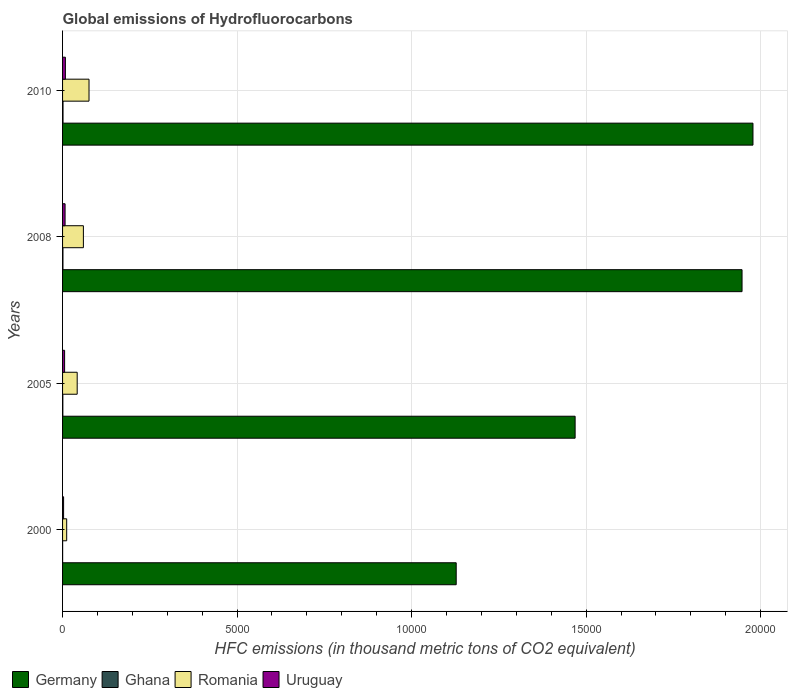How many groups of bars are there?
Your response must be concise. 4. Are the number of bars per tick equal to the number of legend labels?
Your answer should be very brief. Yes. How many bars are there on the 3rd tick from the bottom?
Offer a terse response. 4. Across all years, what is the maximum global emissions of Hydrofluorocarbons in Germany?
Provide a short and direct response. 1.98e+04. In which year was the global emissions of Hydrofluorocarbons in Uruguay minimum?
Offer a terse response. 2000. What is the total global emissions of Hydrofluorocarbons in Romania in the graph?
Your response must be concise. 1891.4. What is the difference between the global emissions of Hydrofluorocarbons in Germany in 2000 and that in 2005?
Make the answer very short. -3407. What is the difference between the global emissions of Hydrofluorocarbons in Romania in 2010 and the global emissions of Hydrofluorocarbons in Uruguay in 2000?
Keep it short and to the point. 728.7. What is the average global emissions of Hydrofluorocarbons in Romania per year?
Provide a succinct answer. 472.85. In the year 2010, what is the difference between the global emissions of Hydrofluorocarbons in Germany and global emissions of Hydrofluorocarbons in Ghana?
Ensure brevity in your answer.  1.98e+04. What is the ratio of the global emissions of Hydrofluorocarbons in Romania in 2005 to that in 2008?
Keep it short and to the point. 0.7. Is the difference between the global emissions of Hydrofluorocarbons in Germany in 2000 and 2005 greater than the difference between the global emissions of Hydrofluorocarbons in Ghana in 2000 and 2005?
Provide a succinct answer. No. What is the difference between the highest and the second highest global emissions of Hydrofluorocarbons in Romania?
Your answer should be compact. 161.6. What is the difference between the highest and the lowest global emissions of Hydrofluorocarbons in Germany?
Your answer should be very brief. 8502.4. In how many years, is the global emissions of Hydrofluorocarbons in Ghana greater than the average global emissions of Hydrofluorocarbons in Ghana taken over all years?
Provide a short and direct response. 2. Is the sum of the global emissions of Hydrofluorocarbons in Ghana in 2005 and 2008 greater than the maximum global emissions of Hydrofluorocarbons in Uruguay across all years?
Your answer should be very brief. No. Is it the case that in every year, the sum of the global emissions of Hydrofluorocarbons in Germany and global emissions of Hydrofluorocarbons in Romania is greater than the sum of global emissions of Hydrofluorocarbons in Uruguay and global emissions of Hydrofluorocarbons in Ghana?
Your answer should be compact. Yes. What does the 1st bar from the bottom in 2010 represents?
Your answer should be very brief. Germany. How many bars are there?
Offer a very short reply. 16. Are all the bars in the graph horizontal?
Offer a very short reply. Yes. What is the difference between two consecutive major ticks on the X-axis?
Offer a terse response. 5000. Does the graph contain any zero values?
Make the answer very short. No. Where does the legend appear in the graph?
Offer a terse response. Bottom left. How many legend labels are there?
Ensure brevity in your answer.  4. What is the title of the graph?
Your answer should be compact. Global emissions of Hydrofluorocarbons. Does "Bahamas" appear as one of the legend labels in the graph?
Offer a terse response. No. What is the label or title of the X-axis?
Make the answer very short. HFC emissions (in thousand metric tons of CO2 equivalent). What is the label or title of the Y-axis?
Give a very brief answer. Years. What is the HFC emissions (in thousand metric tons of CO2 equivalent) in Germany in 2000?
Your answer should be very brief. 1.13e+04. What is the HFC emissions (in thousand metric tons of CO2 equivalent) of Romania in 2000?
Offer a very short reply. 118.2. What is the HFC emissions (in thousand metric tons of CO2 equivalent) in Uruguay in 2000?
Your answer should be very brief. 29.3. What is the HFC emissions (in thousand metric tons of CO2 equivalent) in Germany in 2005?
Offer a very short reply. 1.47e+04. What is the HFC emissions (in thousand metric tons of CO2 equivalent) in Ghana in 2005?
Offer a very short reply. 7.8. What is the HFC emissions (in thousand metric tons of CO2 equivalent) of Romania in 2005?
Keep it short and to the point. 418.8. What is the HFC emissions (in thousand metric tons of CO2 equivalent) in Uruguay in 2005?
Your answer should be very brief. 58.7. What is the HFC emissions (in thousand metric tons of CO2 equivalent) in Germany in 2008?
Keep it short and to the point. 1.95e+04. What is the HFC emissions (in thousand metric tons of CO2 equivalent) of Ghana in 2008?
Keep it short and to the point. 11.2. What is the HFC emissions (in thousand metric tons of CO2 equivalent) of Romania in 2008?
Your answer should be compact. 596.4. What is the HFC emissions (in thousand metric tons of CO2 equivalent) in Uruguay in 2008?
Your answer should be compact. 71.8. What is the HFC emissions (in thousand metric tons of CO2 equivalent) of Germany in 2010?
Provide a succinct answer. 1.98e+04. What is the HFC emissions (in thousand metric tons of CO2 equivalent) of Romania in 2010?
Provide a short and direct response. 758. What is the HFC emissions (in thousand metric tons of CO2 equivalent) of Uruguay in 2010?
Your answer should be very brief. 81. Across all years, what is the maximum HFC emissions (in thousand metric tons of CO2 equivalent) of Germany?
Offer a very short reply. 1.98e+04. Across all years, what is the maximum HFC emissions (in thousand metric tons of CO2 equivalent) of Ghana?
Provide a short and direct response. 13. Across all years, what is the maximum HFC emissions (in thousand metric tons of CO2 equivalent) of Romania?
Provide a short and direct response. 758. Across all years, what is the minimum HFC emissions (in thousand metric tons of CO2 equivalent) of Germany?
Provide a succinct answer. 1.13e+04. Across all years, what is the minimum HFC emissions (in thousand metric tons of CO2 equivalent) of Romania?
Your answer should be very brief. 118.2. Across all years, what is the minimum HFC emissions (in thousand metric tons of CO2 equivalent) of Uruguay?
Your answer should be compact. 29.3. What is the total HFC emissions (in thousand metric tons of CO2 equivalent) of Germany in the graph?
Ensure brevity in your answer.  6.52e+04. What is the total HFC emissions (in thousand metric tons of CO2 equivalent) in Ghana in the graph?
Offer a very short reply. 33.9. What is the total HFC emissions (in thousand metric tons of CO2 equivalent) in Romania in the graph?
Your answer should be compact. 1891.4. What is the total HFC emissions (in thousand metric tons of CO2 equivalent) in Uruguay in the graph?
Your answer should be compact. 240.8. What is the difference between the HFC emissions (in thousand metric tons of CO2 equivalent) in Germany in 2000 and that in 2005?
Your response must be concise. -3407. What is the difference between the HFC emissions (in thousand metric tons of CO2 equivalent) in Ghana in 2000 and that in 2005?
Offer a very short reply. -5.9. What is the difference between the HFC emissions (in thousand metric tons of CO2 equivalent) of Romania in 2000 and that in 2005?
Ensure brevity in your answer.  -300.6. What is the difference between the HFC emissions (in thousand metric tons of CO2 equivalent) of Uruguay in 2000 and that in 2005?
Keep it short and to the point. -29.4. What is the difference between the HFC emissions (in thousand metric tons of CO2 equivalent) in Germany in 2000 and that in 2008?
Ensure brevity in your answer.  -8189.2. What is the difference between the HFC emissions (in thousand metric tons of CO2 equivalent) of Ghana in 2000 and that in 2008?
Provide a succinct answer. -9.3. What is the difference between the HFC emissions (in thousand metric tons of CO2 equivalent) of Romania in 2000 and that in 2008?
Keep it short and to the point. -478.2. What is the difference between the HFC emissions (in thousand metric tons of CO2 equivalent) in Uruguay in 2000 and that in 2008?
Offer a terse response. -42.5. What is the difference between the HFC emissions (in thousand metric tons of CO2 equivalent) of Germany in 2000 and that in 2010?
Your answer should be very brief. -8502.4. What is the difference between the HFC emissions (in thousand metric tons of CO2 equivalent) of Ghana in 2000 and that in 2010?
Keep it short and to the point. -11.1. What is the difference between the HFC emissions (in thousand metric tons of CO2 equivalent) of Romania in 2000 and that in 2010?
Provide a succinct answer. -639.8. What is the difference between the HFC emissions (in thousand metric tons of CO2 equivalent) of Uruguay in 2000 and that in 2010?
Give a very brief answer. -51.7. What is the difference between the HFC emissions (in thousand metric tons of CO2 equivalent) of Germany in 2005 and that in 2008?
Provide a succinct answer. -4782.2. What is the difference between the HFC emissions (in thousand metric tons of CO2 equivalent) of Romania in 2005 and that in 2008?
Keep it short and to the point. -177.6. What is the difference between the HFC emissions (in thousand metric tons of CO2 equivalent) of Uruguay in 2005 and that in 2008?
Keep it short and to the point. -13.1. What is the difference between the HFC emissions (in thousand metric tons of CO2 equivalent) in Germany in 2005 and that in 2010?
Provide a succinct answer. -5095.4. What is the difference between the HFC emissions (in thousand metric tons of CO2 equivalent) in Ghana in 2005 and that in 2010?
Provide a succinct answer. -5.2. What is the difference between the HFC emissions (in thousand metric tons of CO2 equivalent) in Romania in 2005 and that in 2010?
Your answer should be compact. -339.2. What is the difference between the HFC emissions (in thousand metric tons of CO2 equivalent) of Uruguay in 2005 and that in 2010?
Give a very brief answer. -22.3. What is the difference between the HFC emissions (in thousand metric tons of CO2 equivalent) in Germany in 2008 and that in 2010?
Keep it short and to the point. -313.2. What is the difference between the HFC emissions (in thousand metric tons of CO2 equivalent) of Romania in 2008 and that in 2010?
Provide a succinct answer. -161.6. What is the difference between the HFC emissions (in thousand metric tons of CO2 equivalent) of Uruguay in 2008 and that in 2010?
Offer a terse response. -9.2. What is the difference between the HFC emissions (in thousand metric tons of CO2 equivalent) in Germany in 2000 and the HFC emissions (in thousand metric tons of CO2 equivalent) in Ghana in 2005?
Offer a terse response. 1.13e+04. What is the difference between the HFC emissions (in thousand metric tons of CO2 equivalent) of Germany in 2000 and the HFC emissions (in thousand metric tons of CO2 equivalent) of Romania in 2005?
Keep it short and to the point. 1.09e+04. What is the difference between the HFC emissions (in thousand metric tons of CO2 equivalent) of Germany in 2000 and the HFC emissions (in thousand metric tons of CO2 equivalent) of Uruguay in 2005?
Offer a very short reply. 1.12e+04. What is the difference between the HFC emissions (in thousand metric tons of CO2 equivalent) of Ghana in 2000 and the HFC emissions (in thousand metric tons of CO2 equivalent) of Romania in 2005?
Offer a very short reply. -416.9. What is the difference between the HFC emissions (in thousand metric tons of CO2 equivalent) of Ghana in 2000 and the HFC emissions (in thousand metric tons of CO2 equivalent) of Uruguay in 2005?
Your answer should be very brief. -56.8. What is the difference between the HFC emissions (in thousand metric tons of CO2 equivalent) of Romania in 2000 and the HFC emissions (in thousand metric tons of CO2 equivalent) of Uruguay in 2005?
Ensure brevity in your answer.  59.5. What is the difference between the HFC emissions (in thousand metric tons of CO2 equivalent) in Germany in 2000 and the HFC emissions (in thousand metric tons of CO2 equivalent) in Ghana in 2008?
Your answer should be compact. 1.13e+04. What is the difference between the HFC emissions (in thousand metric tons of CO2 equivalent) in Germany in 2000 and the HFC emissions (in thousand metric tons of CO2 equivalent) in Romania in 2008?
Your answer should be very brief. 1.07e+04. What is the difference between the HFC emissions (in thousand metric tons of CO2 equivalent) in Germany in 2000 and the HFC emissions (in thousand metric tons of CO2 equivalent) in Uruguay in 2008?
Keep it short and to the point. 1.12e+04. What is the difference between the HFC emissions (in thousand metric tons of CO2 equivalent) in Ghana in 2000 and the HFC emissions (in thousand metric tons of CO2 equivalent) in Romania in 2008?
Your answer should be compact. -594.5. What is the difference between the HFC emissions (in thousand metric tons of CO2 equivalent) of Ghana in 2000 and the HFC emissions (in thousand metric tons of CO2 equivalent) of Uruguay in 2008?
Your answer should be very brief. -69.9. What is the difference between the HFC emissions (in thousand metric tons of CO2 equivalent) in Romania in 2000 and the HFC emissions (in thousand metric tons of CO2 equivalent) in Uruguay in 2008?
Ensure brevity in your answer.  46.4. What is the difference between the HFC emissions (in thousand metric tons of CO2 equivalent) in Germany in 2000 and the HFC emissions (in thousand metric tons of CO2 equivalent) in Ghana in 2010?
Ensure brevity in your answer.  1.13e+04. What is the difference between the HFC emissions (in thousand metric tons of CO2 equivalent) in Germany in 2000 and the HFC emissions (in thousand metric tons of CO2 equivalent) in Romania in 2010?
Give a very brief answer. 1.05e+04. What is the difference between the HFC emissions (in thousand metric tons of CO2 equivalent) in Germany in 2000 and the HFC emissions (in thousand metric tons of CO2 equivalent) in Uruguay in 2010?
Offer a terse response. 1.12e+04. What is the difference between the HFC emissions (in thousand metric tons of CO2 equivalent) in Ghana in 2000 and the HFC emissions (in thousand metric tons of CO2 equivalent) in Romania in 2010?
Your answer should be compact. -756.1. What is the difference between the HFC emissions (in thousand metric tons of CO2 equivalent) in Ghana in 2000 and the HFC emissions (in thousand metric tons of CO2 equivalent) in Uruguay in 2010?
Offer a very short reply. -79.1. What is the difference between the HFC emissions (in thousand metric tons of CO2 equivalent) of Romania in 2000 and the HFC emissions (in thousand metric tons of CO2 equivalent) of Uruguay in 2010?
Offer a terse response. 37.2. What is the difference between the HFC emissions (in thousand metric tons of CO2 equivalent) of Germany in 2005 and the HFC emissions (in thousand metric tons of CO2 equivalent) of Ghana in 2008?
Offer a terse response. 1.47e+04. What is the difference between the HFC emissions (in thousand metric tons of CO2 equivalent) in Germany in 2005 and the HFC emissions (in thousand metric tons of CO2 equivalent) in Romania in 2008?
Your response must be concise. 1.41e+04. What is the difference between the HFC emissions (in thousand metric tons of CO2 equivalent) in Germany in 2005 and the HFC emissions (in thousand metric tons of CO2 equivalent) in Uruguay in 2008?
Provide a succinct answer. 1.46e+04. What is the difference between the HFC emissions (in thousand metric tons of CO2 equivalent) in Ghana in 2005 and the HFC emissions (in thousand metric tons of CO2 equivalent) in Romania in 2008?
Ensure brevity in your answer.  -588.6. What is the difference between the HFC emissions (in thousand metric tons of CO2 equivalent) in Ghana in 2005 and the HFC emissions (in thousand metric tons of CO2 equivalent) in Uruguay in 2008?
Offer a terse response. -64. What is the difference between the HFC emissions (in thousand metric tons of CO2 equivalent) in Romania in 2005 and the HFC emissions (in thousand metric tons of CO2 equivalent) in Uruguay in 2008?
Provide a succinct answer. 347. What is the difference between the HFC emissions (in thousand metric tons of CO2 equivalent) of Germany in 2005 and the HFC emissions (in thousand metric tons of CO2 equivalent) of Ghana in 2010?
Offer a terse response. 1.47e+04. What is the difference between the HFC emissions (in thousand metric tons of CO2 equivalent) of Germany in 2005 and the HFC emissions (in thousand metric tons of CO2 equivalent) of Romania in 2010?
Ensure brevity in your answer.  1.39e+04. What is the difference between the HFC emissions (in thousand metric tons of CO2 equivalent) of Germany in 2005 and the HFC emissions (in thousand metric tons of CO2 equivalent) of Uruguay in 2010?
Offer a very short reply. 1.46e+04. What is the difference between the HFC emissions (in thousand metric tons of CO2 equivalent) in Ghana in 2005 and the HFC emissions (in thousand metric tons of CO2 equivalent) in Romania in 2010?
Your answer should be very brief. -750.2. What is the difference between the HFC emissions (in thousand metric tons of CO2 equivalent) in Ghana in 2005 and the HFC emissions (in thousand metric tons of CO2 equivalent) in Uruguay in 2010?
Offer a terse response. -73.2. What is the difference between the HFC emissions (in thousand metric tons of CO2 equivalent) in Romania in 2005 and the HFC emissions (in thousand metric tons of CO2 equivalent) in Uruguay in 2010?
Your answer should be very brief. 337.8. What is the difference between the HFC emissions (in thousand metric tons of CO2 equivalent) of Germany in 2008 and the HFC emissions (in thousand metric tons of CO2 equivalent) of Ghana in 2010?
Offer a very short reply. 1.95e+04. What is the difference between the HFC emissions (in thousand metric tons of CO2 equivalent) of Germany in 2008 and the HFC emissions (in thousand metric tons of CO2 equivalent) of Romania in 2010?
Make the answer very short. 1.87e+04. What is the difference between the HFC emissions (in thousand metric tons of CO2 equivalent) in Germany in 2008 and the HFC emissions (in thousand metric tons of CO2 equivalent) in Uruguay in 2010?
Keep it short and to the point. 1.94e+04. What is the difference between the HFC emissions (in thousand metric tons of CO2 equivalent) of Ghana in 2008 and the HFC emissions (in thousand metric tons of CO2 equivalent) of Romania in 2010?
Offer a terse response. -746.8. What is the difference between the HFC emissions (in thousand metric tons of CO2 equivalent) of Ghana in 2008 and the HFC emissions (in thousand metric tons of CO2 equivalent) of Uruguay in 2010?
Keep it short and to the point. -69.8. What is the difference between the HFC emissions (in thousand metric tons of CO2 equivalent) of Romania in 2008 and the HFC emissions (in thousand metric tons of CO2 equivalent) of Uruguay in 2010?
Your response must be concise. 515.4. What is the average HFC emissions (in thousand metric tons of CO2 equivalent) of Germany per year?
Your answer should be compact. 1.63e+04. What is the average HFC emissions (in thousand metric tons of CO2 equivalent) in Ghana per year?
Give a very brief answer. 8.47. What is the average HFC emissions (in thousand metric tons of CO2 equivalent) of Romania per year?
Provide a succinct answer. 472.85. What is the average HFC emissions (in thousand metric tons of CO2 equivalent) in Uruguay per year?
Offer a terse response. 60.2. In the year 2000, what is the difference between the HFC emissions (in thousand metric tons of CO2 equivalent) of Germany and HFC emissions (in thousand metric tons of CO2 equivalent) of Ghana?
Your response must be concise. 1.13e+04. In the year 2000, what is the difference between the HFC emissions (in thousand metric tons of CO2 equivalent) of Germany and HFC emissions (in thousand metric tons of CO2 equivalent) of Romania?
Offer a very short reply. 1.12e+04. In the year 2000, what is the difference between the HFC emissions (in thousand metric tons of CO2 equivalent) in Germany and HFC emissions (in thousand metric tons of CO2 equivalent) in Uruguay?
Your answer should be very brief. 1.12e+04. In the year 2000, what is the difference between the HFC emissions (in thousand metric tons of CO2 equivalent) of Ghana and HFC emissions (in thousand metric tons of CO2 equivalent) of Romania?
Ensure brevity in your answer.  -116.3. In the year 2000, what is the difference between the HFC emissions (in thousand metric tons of CO2 equivalent) in Ghana and HFC emissions (in thousand metric tons of CO2 equivalent) in Uruguay?
Give a very brief answer. -27.4. In the year 2000, what is the difference between the HFC emissions (in thousand metric tons of CO2 equivalent) of Romania and HFC emissions (in thousand metric tons of CO2 equivalent) of Uruguay?
Your answer should be very brief. 88.9. In the year 2005, what is the difference between the HFC emissions (in thousand metric tons of CO2 equivalent) in Germany and HFC emissions (in thousand metric tons of CO2 equivalent) in Ghana?
Provide a succinct answer. 1.47e+04. In the year 2005, what is the difference between the HFC emissions (in thousand metric tons of CO2 equivalent) in Germany and HFC emissions (in thousand metric tons of CO2 equivalent) in Romania?
Give a very brief answer. 1.43e+04. In the year 2005, what is the difference between the HFC emissions (in thousand metric tons of CO2 equivalent) of Germany and HFC emissions (in thousand metric tons of CO2 equivalent) of Uruguay?
Offer a terse response. 1.46e+04. In the year 2005, what is the difference between the HFC emissions (in thousand metric tons of CO2 equivalent) in Ghana and HFC emissions (in thousand metric tons of CO2 equivalent) in Romania?
Provide a short and direct response. -411. In the year 2005, what is the difference between the HFC emissions (in thousand metric tons of CO2 equivalent) in Ghana and HFC emissions (in thousand metric tons of CO2 equivalent) in Uruguay?
Your answer should be very brief. -50.9. In the year 2005, what is the difference between the HFC emissions (in thousand metric tons of CO2 equivalent) of Romania and HFC emissions (in thousand metric tons of CO2 equivalent) of Uruguay?
Your answer should be very brief. 360.1. In the year 2008, what is the difference between the HFC emissions (in thousand metric tons of CO2 equivalent) in Germany and HFC emissions (in thousand metric tons of CO2 equivalent) in Ghana?
Provide a short and direct response. 1.95e+04. In the year 2008, what is the difference between the HFC emissions (in thousand metric tons of CO2 equivalent) of Germany and HFC emissions (in thousand metric tons of CO2 equivalent) of Romania?
Provide a succinct answer. 1.89e+04. In the year 2008, what is the difference between the HFC emissions (in thousand metric tons of CO2 equivalent) in Germany and HFC emissions (in thousand metric tons of CO2 equivalent) in Uruguay?
Offer a terse response. 1.94e+04. In the year 2008, what is the difference between the HFC emissions (in thousand metric tons of CO2 equivalent) in Ghana and HFC emissions (in thousand metric tons of CO2 equivalent) in Romania?
Ensure brevity in your answer.  -585.2. In the year 2008, what is the difference between the HFC emissions (in thousand metric tons of CO2 equivalent) of Ghana and HFC emissions (in thousand metric tons of CO2 equivalent) of Uruguay?
Offer a very short reply. -60.6. In the year 2008, what is the difference between the HFC emissions (in thousand metric tons of CO2 equivalent) of Romania and HFC emissions (in thousand metric tons of CO2 equivalent) of Uruguay?
Offer a very short reply. 524.6. In the year 2010, what is the difference between the HFC emissions (in thousand metric tons of CO2 equivalent) in Germany and HFC emissions (in thousand metric tons of CO2 equivalent) in Ghana?
Keep it short and to the point. 1.98e+04. In the year 2010, what is the difference between the HFC emissions (in thousand metric tons of CO2 equivalent) of Germany and HFC emissions (in thousand metric tons of CO2 equivalent) of Romania?
Provide a short and direct response. 1.90e+04. In the year 2010, what is the difference between the HFC emissions (in thousand metric tons of CO2 equivalent) in Germany and HFC emissions (in thousand metric tons of CO2 equivalent) in Uruguay?
Your answer should be compact. 1.97e+04. In the year 2010, what is the difference between the HFC emissions (in thousand metric tons of CO2 equivalent) of Ghana and HFC emissions (in thousand metric tons of CO2 equivalent) of Romania?
Keep it short and to the point. -745. In the year 2010, what is the difference between the HFC emissions (in thousand metric tons of CO2 equivalent) in Ghana and HFC emissions (in thousand metric tons of CO2 equivalent) in Uruguay?
Ensure brevity in your answer.  -68. In the year 2010, what is the difference between the HFC emissions (in thousand metric tons of CO2 equivalent) in Romania and HFC emissions (in thousand metric tons of CO2 equivalent) in Uruguay?
Make the answer very short. 677. What is the ratio of the HFC emissions (in thousand metric tons of CO2 equivalent) of Germany in 2000 to that in 2005?
Make the answer very short. 0.77. What is the ratio of the HFC emissions (in thousand metric tons of CO2 equivalent) of Ghana in 2000 to that in 2005?
Your answer should be compact. 0.24. What is the ratio of the HFC emissions (in thousand metric tons of CO2 equivalent) in Romania in 2000 to that in 2005?
Ensure brevity in your answer.  0.28. What is the ratio of the HFC emissions (in thousand metric tons of CO2 equivalent) in Uruguay in 2000 to that in 2005?
Make the answer very short. 0.5. What is the ratio of the HFC emissions (in thousand metric tons of CO2 equivalent) in Germany in 2000 to that in 2008?
Your answer should be very brief. 0.58. What is the ratio of the HFC emissions (in thousand metric tons of CO2 equivalent) of Ghana in 2000 to that in 2008?
Ensure brevity in your answer.  0.17. What is the ratio of the HFC emissions (in thousand metric tons of CO2 equivalent) of Romania in 2000 to that in 2008?
Provide a short and direct response. 0.2. What is the ratio of the HFC emissions (in thousand metric tons of CO2 equivalent) of Uruguay in 2000 to that in 2008?
Give a very brief answer. 0.41. What is the ratio of the HFC emissions (in thousand metric tons of CO2 equivalent) of Germany in 2000 to that in 2010?
Your answer should be very brief. 0.57. What is the ratio of the HFC emissions (in thousand metric tons of CO2 equivalent) in Ghana in 2000 to that in 2010?
Your response must be concise. 0.15. What is the ratio of the HFC emissions (in thousand metric tons of CO2 equivalent) in Romania in 2000 to that in 2010?
Keep it short and to the point. 0.16. What is the ratio of the HFC emissions (in thousand metric tons of CO2 equivalent) in Uruguay in 2000 to that in 2010?
Give a very brief answer. 0.36. What is the ratio of the HFC emissions (in thousand metric tons of CO2 equivalent) of Germany in 2005 to that in 2008?
Provide a succinct answer. 0.75. What is the ratio of the HFC emissions (in thousand metric tons of CO2 equivalent) in Ghana in 2005 to that in 2008?
Provide a short and direct response. 0.7. What is the ratio of the HFC emissions (in thousand metric tons of CO2 equivalent) in Romania in 2005 to that in 2008?
Provide a succinct answer. 0.7. What is the ratio of the HFC emissions (in thousand metric tons of CO2 equivalent) of Uruguay in 2005 to that in 2008?
Your answer should be compact. 0.82. What is the ratio of the HFC emissions (in thousand metric tons of CO2 equivalent) in Germany in 2005 to that in 2010?
Provide a short and direct response. 0.74. What is the ratio of the HFC emissions (in thousand metric tons of CO2 equivalent) in Romania in 2005 to that in 2010?
Your response must be concise. 0.55. What is the ratio of the HFC emissions (in thousand metric tons of CO2 equivalent) in Uruguay in 2005 to that in 2010?
Your answer should be very brief. 0.72. What is the ratio of the HFC emissions (in thousand metric tons of CO2 equivalent) of Germany in 2008 to that in 2010?
Keep it short and to the point. 0.98. What is the ratio of the HFC emissions (in thousand metric tons of CO2 equivalent) of Ghana in 2008 to that in 2010?
Your answer should be compact. 0.86. What is the ratio of the HFC emissions (in thousand metric tons of CO2 equivalent) of Romania in 2008 to that in 2010?
Your answer should be very brief. 0.79. What is the ratio of the HFC emissions (in thousand metric tons of CO2 equivalent) in Uruguay in 2008 to that in 2010?
Your answer should be compact. 0.89. What is the difference between the highest and the second highest HFC emissions (in thousand metric tons of CO2 equivalent) in Germany?
Your answer should be very brief. 313.2. What is the difference between the highest and the second highest HFC emissions (in thousand metric tons of CO2 equivalent) of Romania?
Your response must be concise. 161.6. What is the difference between the highest and the second highest HFC emissions (in thousand metric tons of CO2 equivalent) in Uruguay?
Ensure brevity in your answer.  9.2. What is the difference between the highest and the lowest HFC emissions (in thousand metric tons of CO2 equivalent) of Germany?
Keep it short and to the point. 8502.4. What is the difference between the highest and the lowest HFC emissions (in thousand metric tons of CO2 equivalent) in Romania?
Offer a very short reply. 639.8. What is the difference between the highest and the lowest HFC emissions (in thousand metric tons of CO2 equivalent) in Uruguay?
Offer a very short reply. 51.7. 